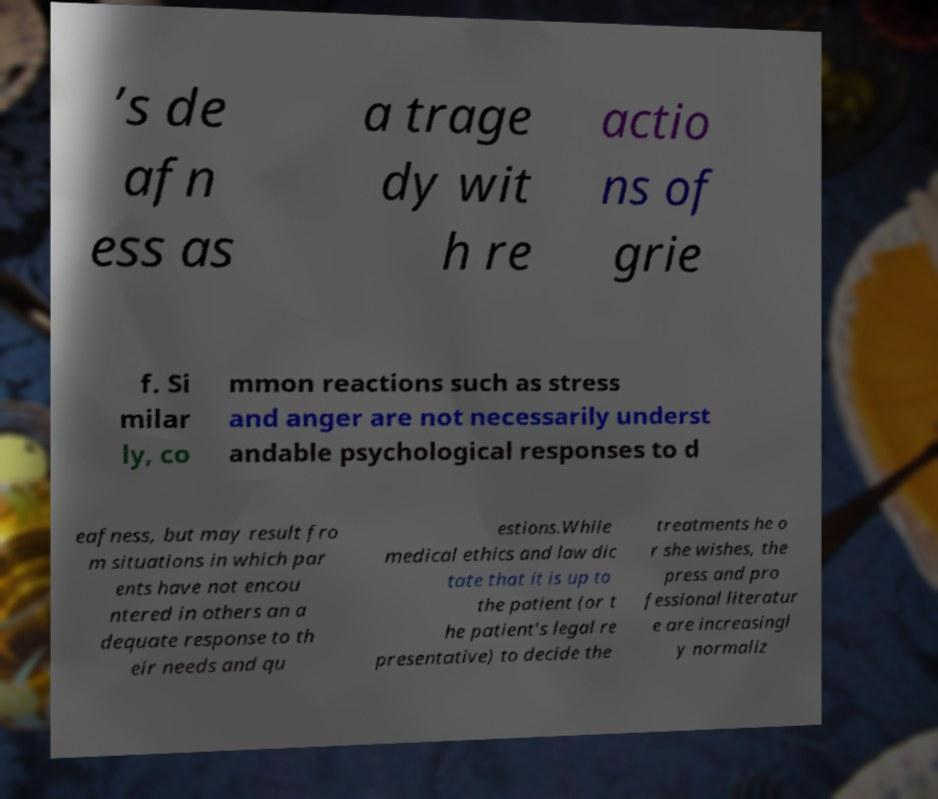For documentation purposes, I need the text within this image transcribed. Could you provide that? ’s de afn ess as a trage dy wit h re actio ns of grie f. Si milar ly, co mmon reactions such as stress and anger are not necessarily underst andable psychological responses to d eafness, but may result fro m situations in which par ents have not encou ntered in others an a dequate response to th eir needs and qu estions.While medical ethics and law dic tate that it is up to the patient (or t he patient's legal re presentative) to decide the treatments he o r she wishes, the press and pro fessional literatur e are increasingl y normaliz 